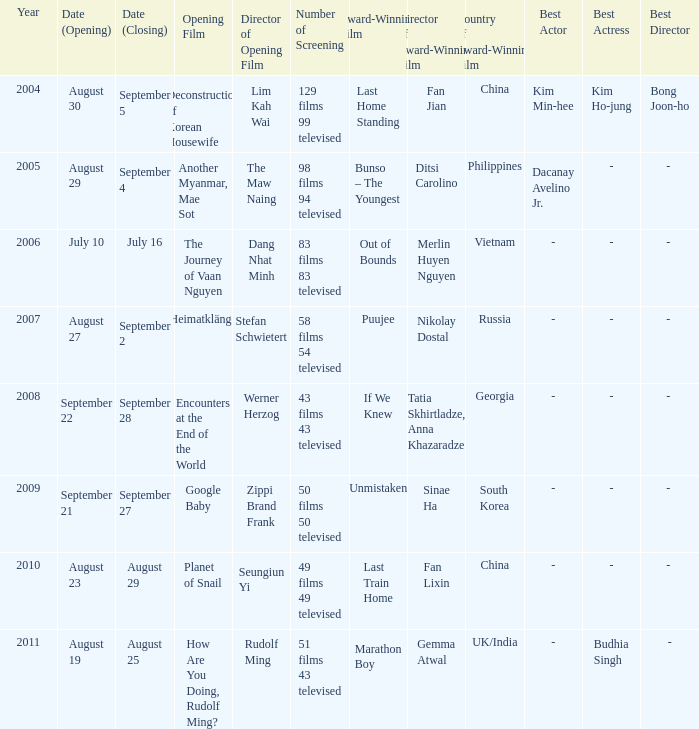How many number of screenings have an opening film of the journey of vaan nguyen? 1.0. 